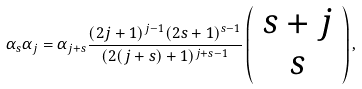Convert formula to latex. <formula><loc_0><loc_0><loc_500><loc_500>\alpha _ { s } \alpha _ { j } = \alpha _ { j + s } \frac { ( 2 j + 1 ) ^ { j - 1 } ( 2 s + 1 ) ^ { s - 1 } } { ( 2 ( j + s ) + 1 ) ^ { j + s - 1 } } \left ( \begin{array} { c } s + j \\ s \end{array} \right ) ,</formula> 